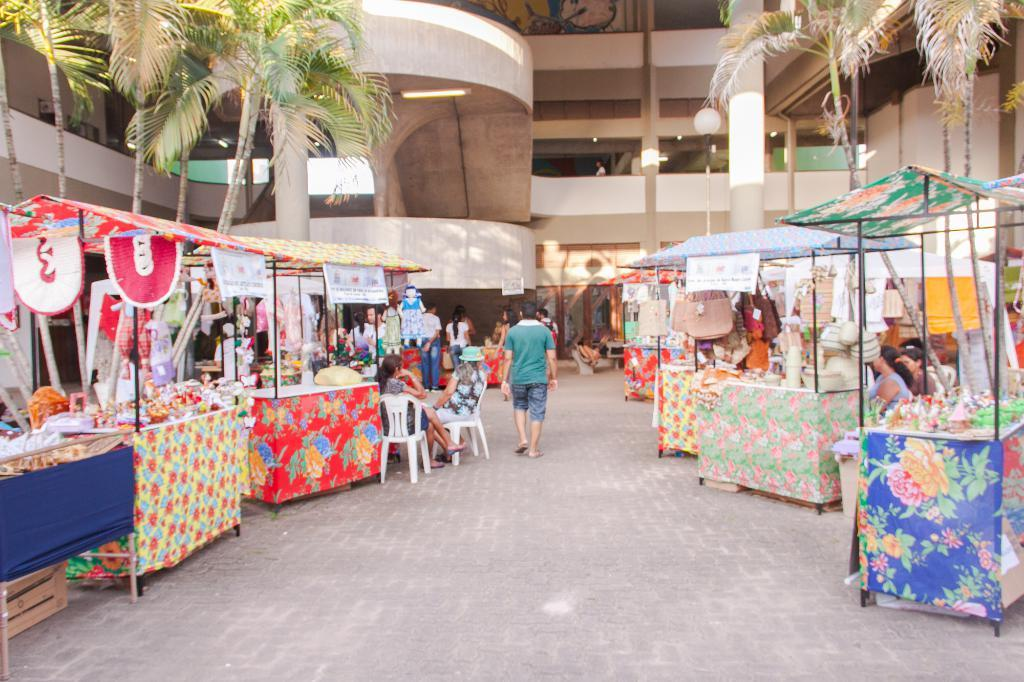What type of structures are present in the image? There are stalls with banners in the image. What can be seen on the ground near the stalls? There are bags visible in the image. What is being sold or displayed at the stalls? There are things on display at the stalls. What type of building is in the image? There is a building in the image. What is in front of the building? Trees and a light pole are present in front of the building. Who is present in the image? People are visible in the image. What are some people doing in the image? Some people are sitting on chairs. What type of paste is being used to stick the dolls on the crown in the image? There is no paste, dolls, or crown present in the image. 